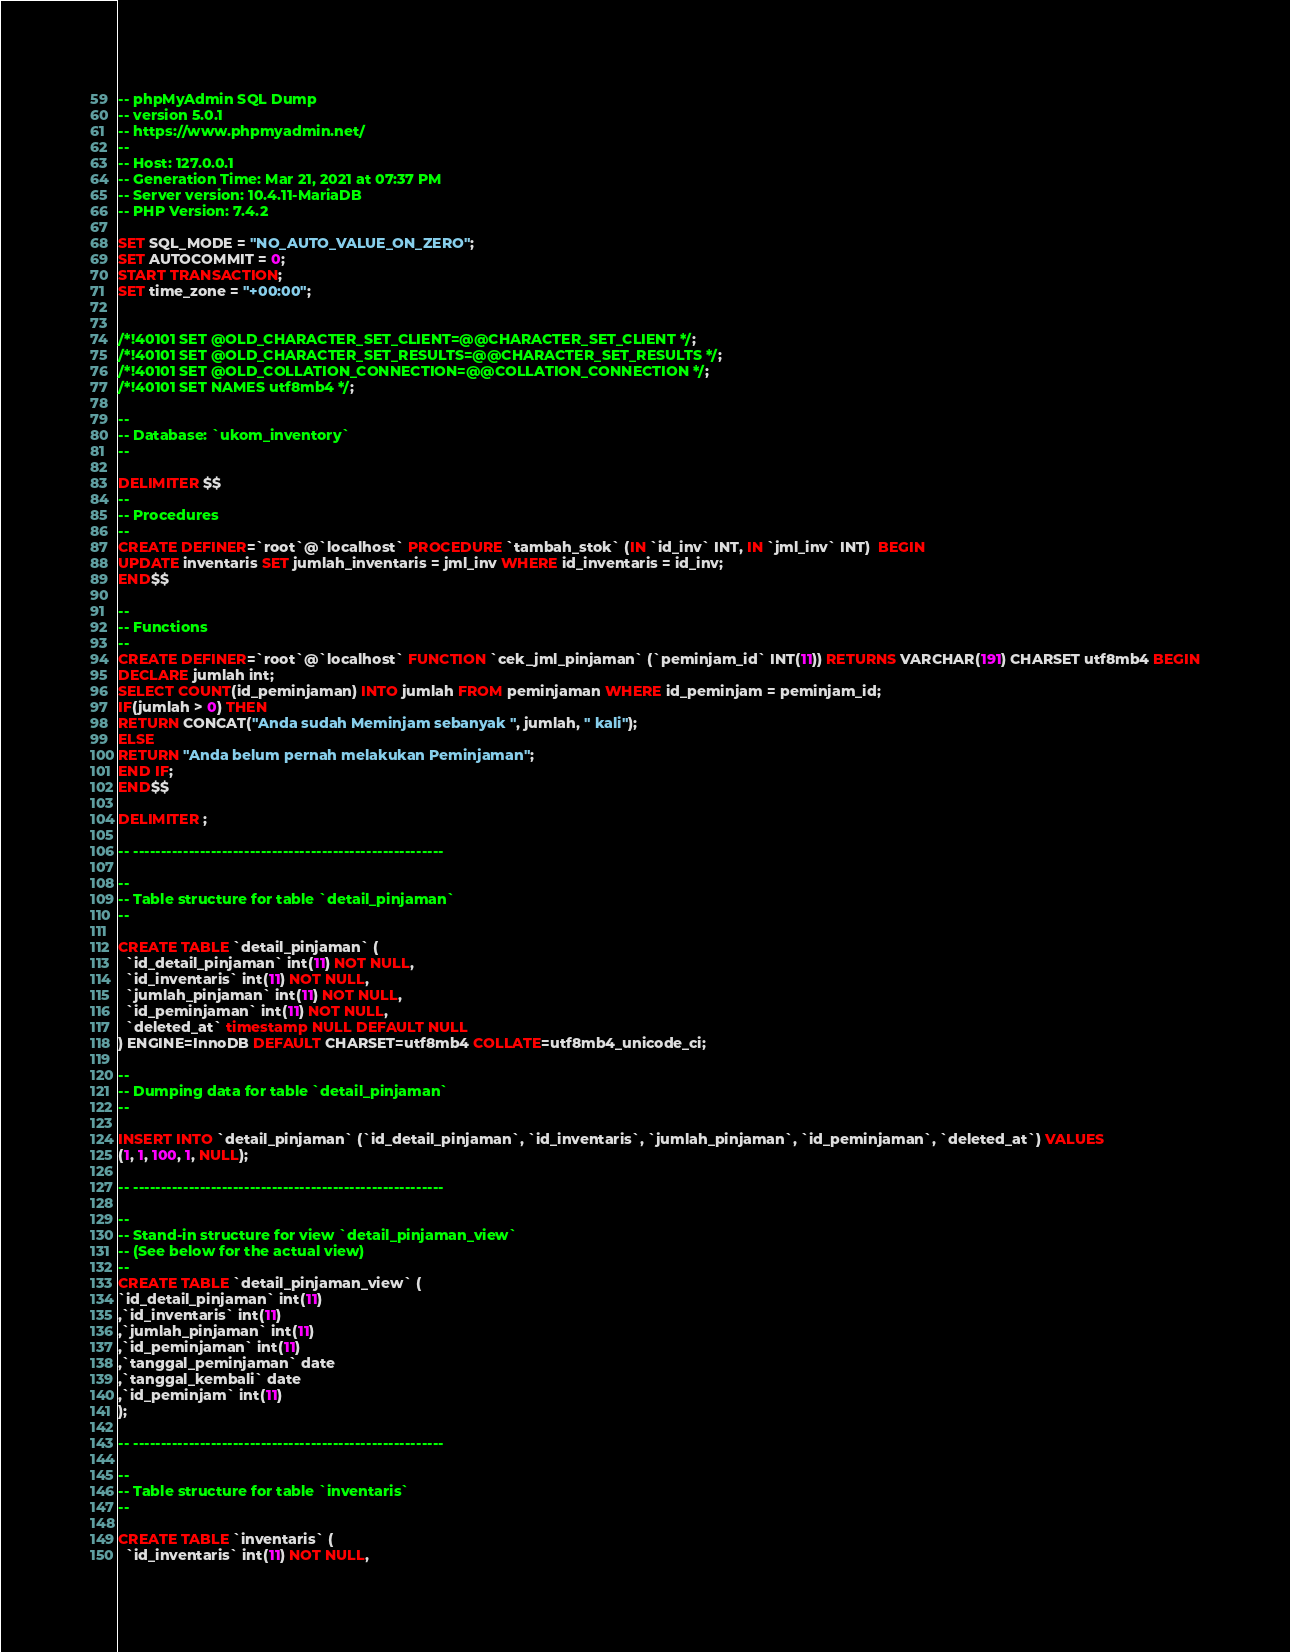Convert code to text. <code><loc_0><loc_0><loc_500><loc_500><_SQL_>-- phpMyAdmin SQL Dump
-- version 5.0.1
-- https://www.phpmyadmin.net/
--
-- Host: 127.0.0.1
-- Generation Time: Mar 21, 2021 at 07:37 PM
-- Server version: 10.4.11-MariaDB
-- PHP Version: 7.4.2

SET SQL_MODE = "NO_AUTO_VALUE_ON_ZERO";
SET AUTOCOMMIT = 0;
START TRANSACTION;
SET time_zone = "+00:00";


/*!40101 SET @OLD_CHARACTER_SET_CLIENT=@@CHARACTER_SET_CLIENT */;
/*!40101 SET @OLD_CHARACTER_SET_RESULTS=@@CHARACTER_SET_RESULTS */;
/*!40101 SET @OLD_COLLATION_CONNECTION=@@COLLATION_CONNECTION */;
/*!40101 SET NAMES utf8mb4 */;

--
-- Database: `ukom_inventory`
--

DELIMITER $$
--
-- Procedures
--
CREATE DEFINER=`root`@`localhost` PROCEDURE `tambah_stok` (IN `id_inv` INT, IN `jml_inv` INT)  BEGIN
UPDATE inventaris SET jumlah_inventaris = jml_inv WHERE id_inventaris = id_inv;
END$$

--
-- Functions
--
CREATE DEFINER=`root`@`localhost` FUNCTION `cek_jml_pinjaman` (`peminjam_id` INT(11)) RETURNS VARCHAR(191) CHARSET utf8mb4 BEGIN
DECLARE jumlah int;
SELECT COUNT(id_peminjaman) INTO jumlah FROM peminjaman WHERE id_peminjam = peminjam_id;
IF(jumlah > 0) THEN 
RETURN CONCAT("Anda sudah Meminjam sebanyak ", jumlah, " kali");
ELSE 
RETURN "Anda belum pernah melakukan Peminjaman";
END IF;
END$$

DELIMITER ;

-- --------------------------------------------------------

--
-- Table structure for table `detail_pinjaman`
--

CREATE TABLE `detail_pinjaman` (
  `id_detail_pinjaman` int(11) NOT NULL,
  `id_inventaris` int(11) NOT NULL,
  `jumlah_pinjaman` int(11) NOT NULL,
  `id_peminjaman` int(11) NOT NULL,
  `deleted_at` timestamp NULL DEFAULT NULL
) ENGINE=InnoDB DEFAULT CHARSET=utf8mb4 COLLATE=utf8mb4_unicode_ci;

--
-- Dumping data for table `detail_pinjaman`
--

INSERT INTO `detail_pinjaman` (`id_detail_pinjaman`, `id_inventaris`, `jumlah_pinjaman`, `id_peminjaman`, `deleted_at`) VALUES
(1, 1, 100, 1, NULL);

-- --------------------------------------------------------

--
-- Stand-in structure for view `detail_pinjaman_view`
-- (See below for the actual view)
--
CREATE TABLE `detail_pinjaman_view` (
`id_detail_pinjaman` int(11)
,`id_inventaris` int(11)
,`jumlah_pinjaman` int(11)
,`id_peminjaman` int(11)
,`tanggal_peminjaman` date
,`tanggal_kembali` date
,`id_peminjam` int(11)
);

-- --------------------------------------------------------

--
-- Table structure for table `inventaris`
--

CREATE TABLE `inventaris` (
  `id_inventaris` int(11) NOT NULL,</code> 